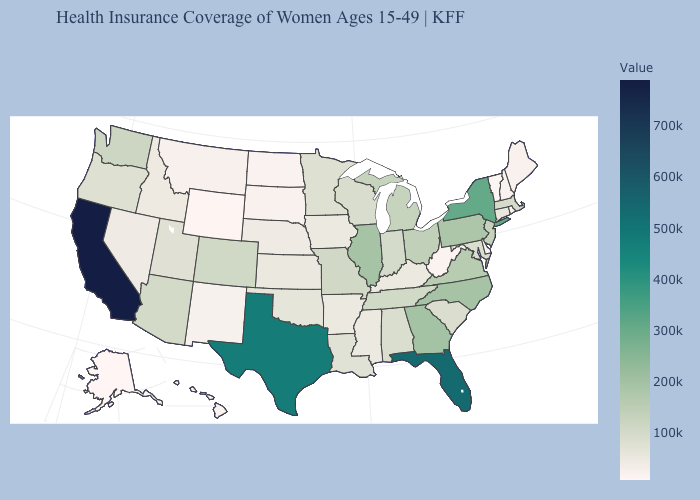Which states have the lowest value in the USA?
Give a very brief answer. Alaska. Does Texas have the highest value in the USA?
Be succinct. No. Among the states that border Georgia , does North Carolina have the lowest value?
Be succinct. No. Which states hav the highest value in the Northeast?
Be succinct. New York. 